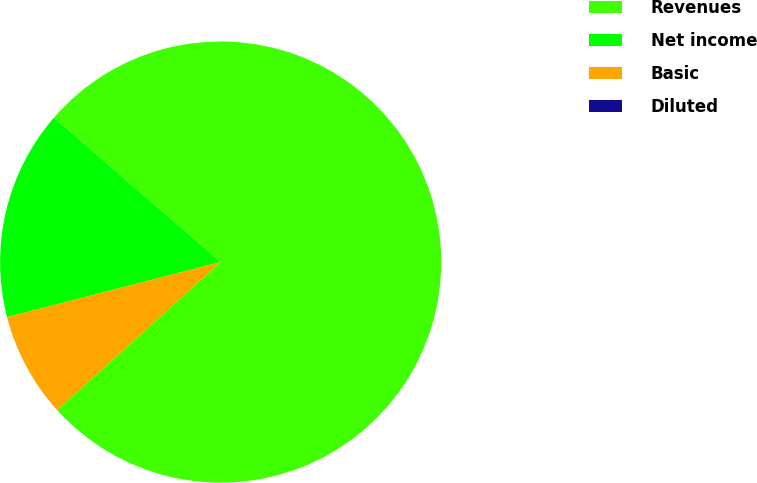<chart> <loc_0><loc_0><loc_500><loc_500><pie_chart><fcel>Revenues<fcel>Net income<fcel>Basic<fcel>Diluted<nl><fcel>76.92%<fcel>15.38%<fcel>7.69%<fcel>0.0%<nl></chart> 